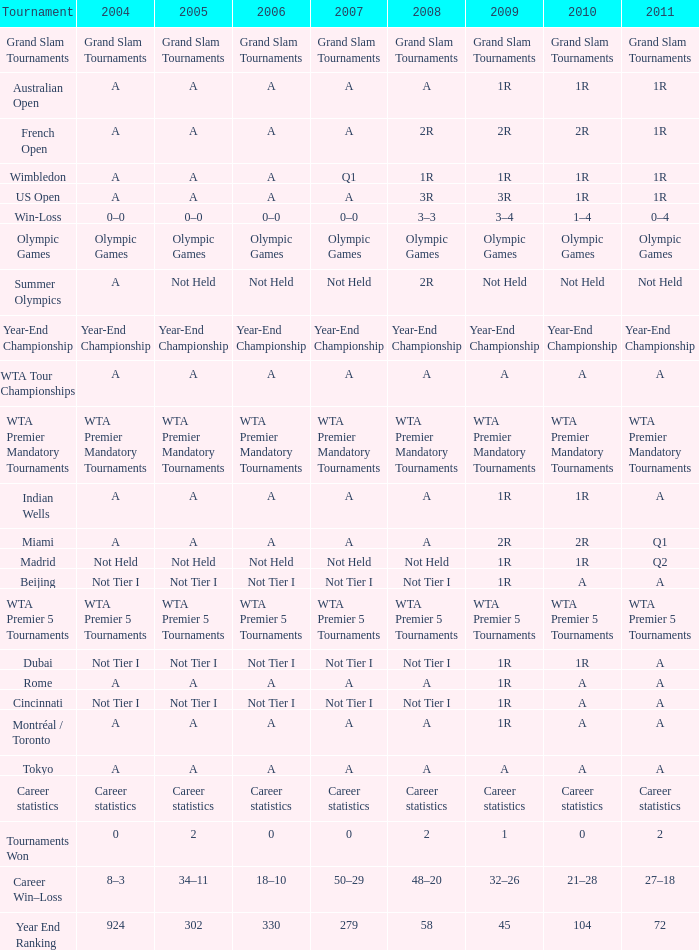When 2009 is denoted as "1", how can we represent 2010? 0.0. 